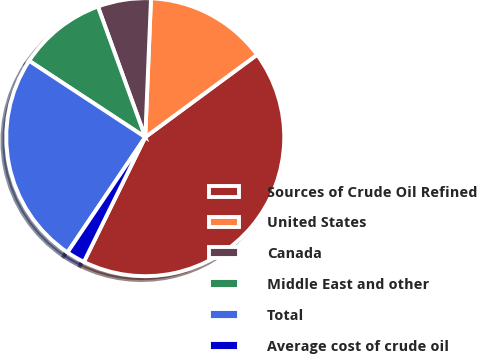Convert chart. <chart><loc_0><loc_0><loc_500><loc_500><pie_chart><fcel>Sources of Crude Oil Refined<fcel>United States<fcel>Canada<fcel>Middle East and other<fcel>Total<fcel>Average cost of crude oil<nl><fcel>42.39%<fcel>14.23%<fcel>6.19%<fcel>10.21%<fcel>24.81%<fcel>2.17%<nl></chart> 